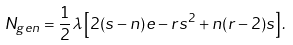<formula> <loc_0><loc_0><loc_500><loc_500>N _ { g e n } = \frac { 1 } { 2 } \lambda \left [ 2 ( s - n ) e - r s ^ { 2 } + n ( r - 2 ) s \right ] .</formula> 